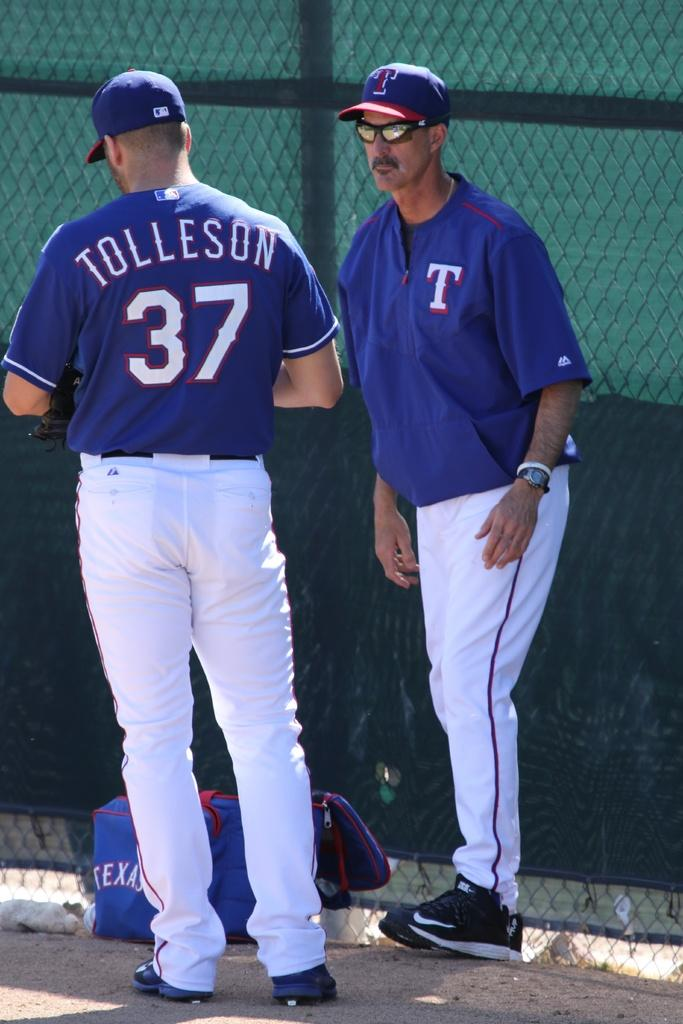<image>
Give a short and clear explanation of the subsequent image. Baseball player wearing a jersey which says the letter T on it. 